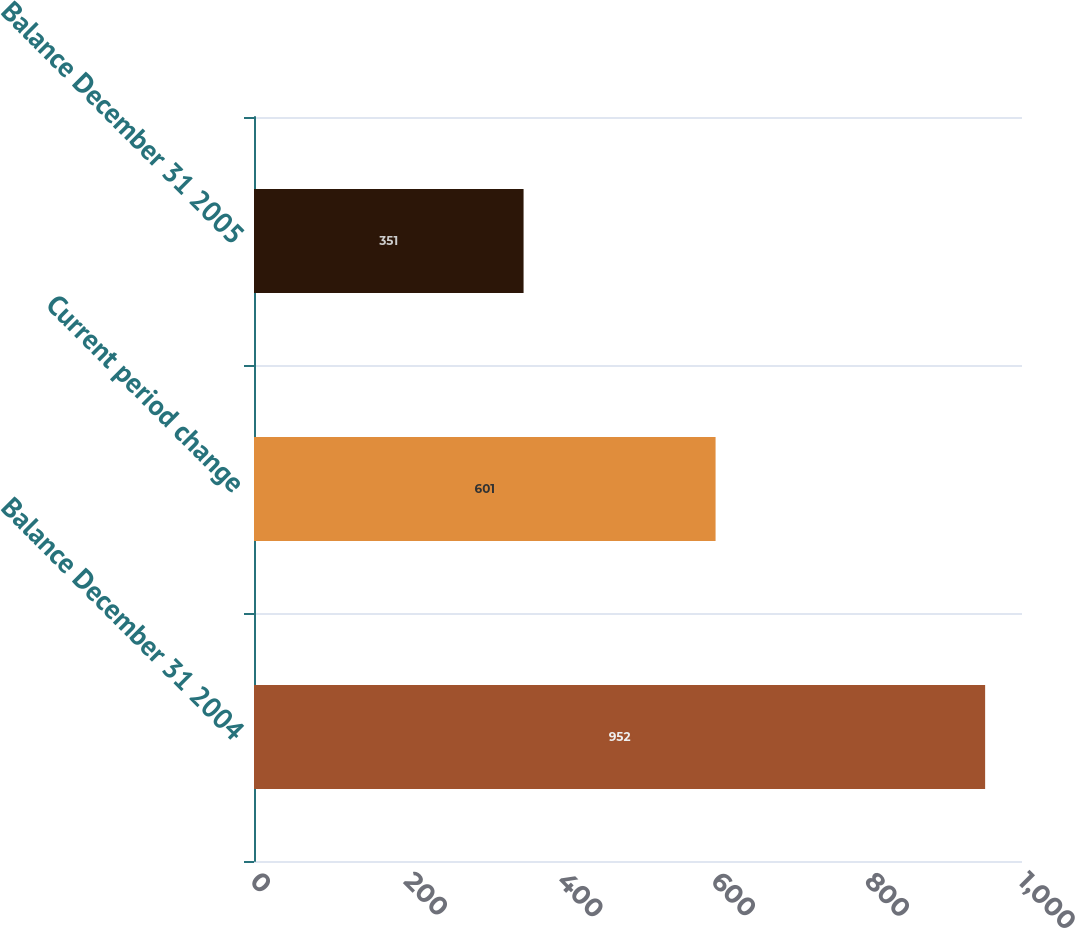Convert chart to OTSL. <chart><loc_0><loc_0><loc_500><loc_500><bar_chart><fcel>Balance December 31 2004<fcel>Current period change<fcel>Balance December 31 2005<nl><fcel>952<fcel>601<fcel>351<nl></chart> 